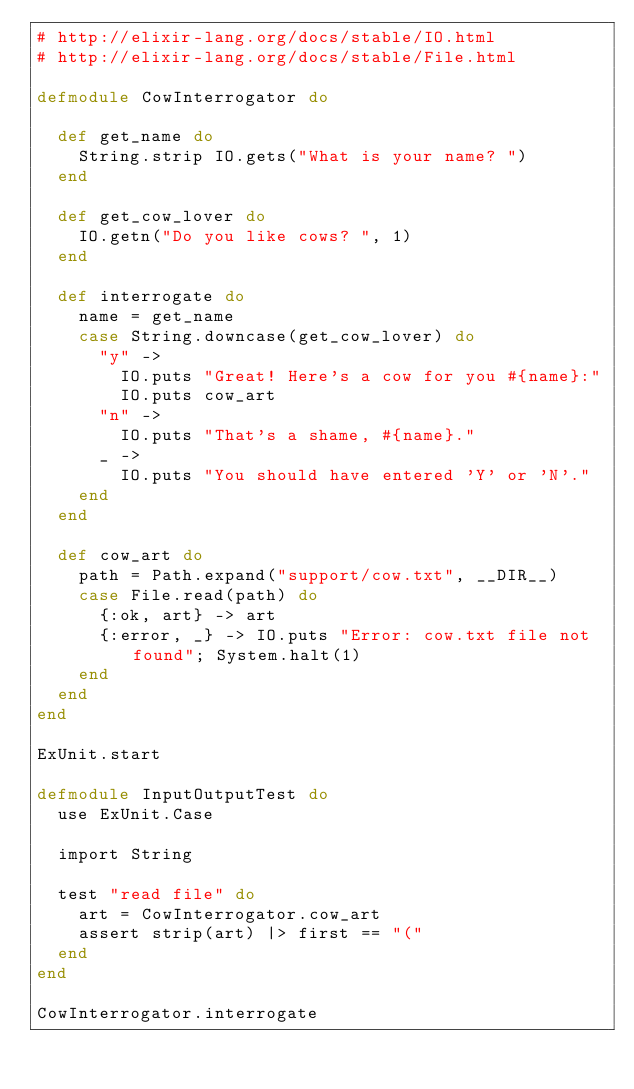<code> <loc_0><loc_0><loc_500><loc_500><_Elixir_># http://elixir-lang.org/docs/stable/IO.html
# http://elixir-lang.org/docs/stable/File.html

defmodule CowInterrogator do

  def get_name do
    String.strip IO.gets("What is your name? ")
  end

  def get_cow_lover do
    IO.getn("Do you like cows? ", 1)
  end

  def interrogate do
    name = get_name
    case String.downcase(get_cow_lover) do
      "y" ->
        IO.puts "Great! Here's a cow for you #{name}:"
        IO.puts cow_art
      "n" ->
        IO.puts "That's a shame, #{name}."
      _ ->
        IO.puts "You should have entered 'Y' or 'N'."
    end
  end

  def cow_art do
    path = Path.expand("support/cow.txt", __DIR__)
    case File.read(path) do
      {:ok, art} -> art
      {:error, _} -> IO.puts "Error: cow.txt file not found"; System.halt(1)
    end
  end
end

ExUnit.start

defmodule InputOutputTest do
  use ExUnit.Case

  import String

  test "read file" do
    art = CowInterrogator.cow_art
    assert strip(art) |> first == "("
  end
end

CowInterrogator.interrogate
</code> 